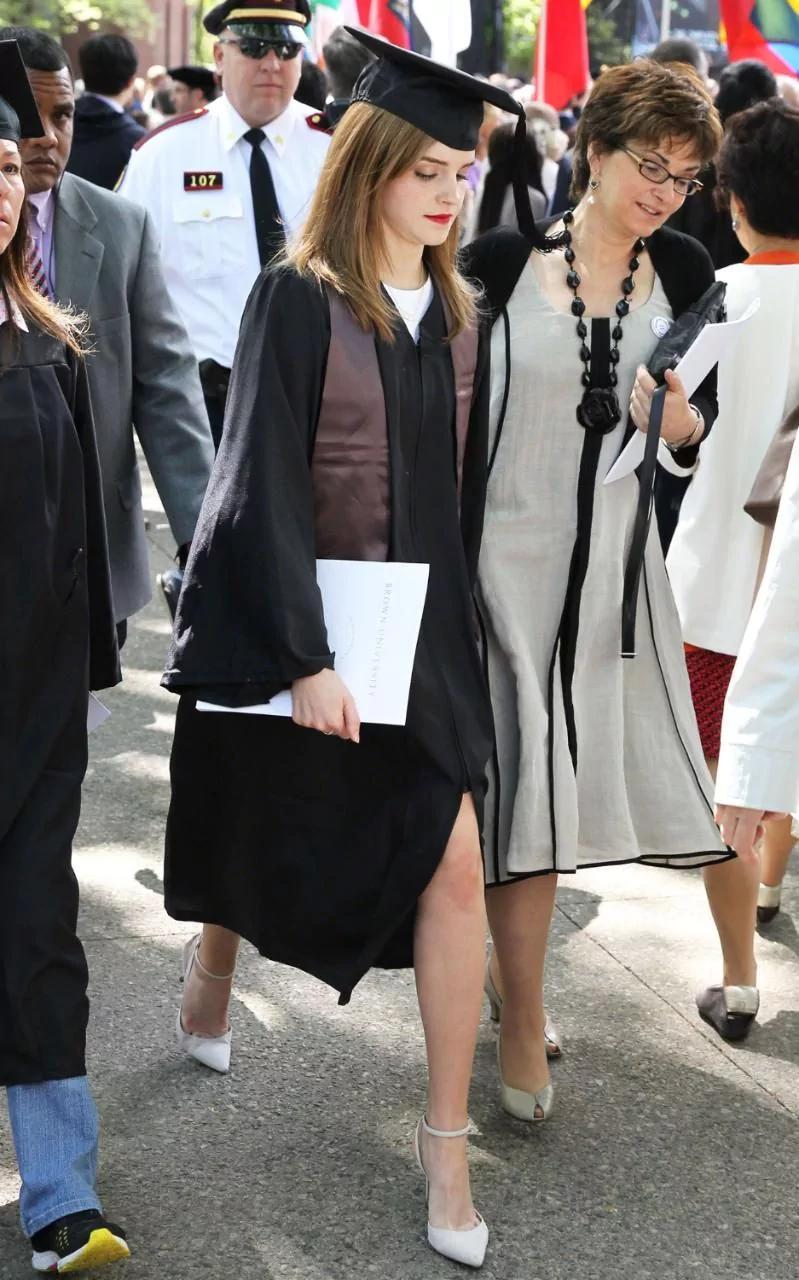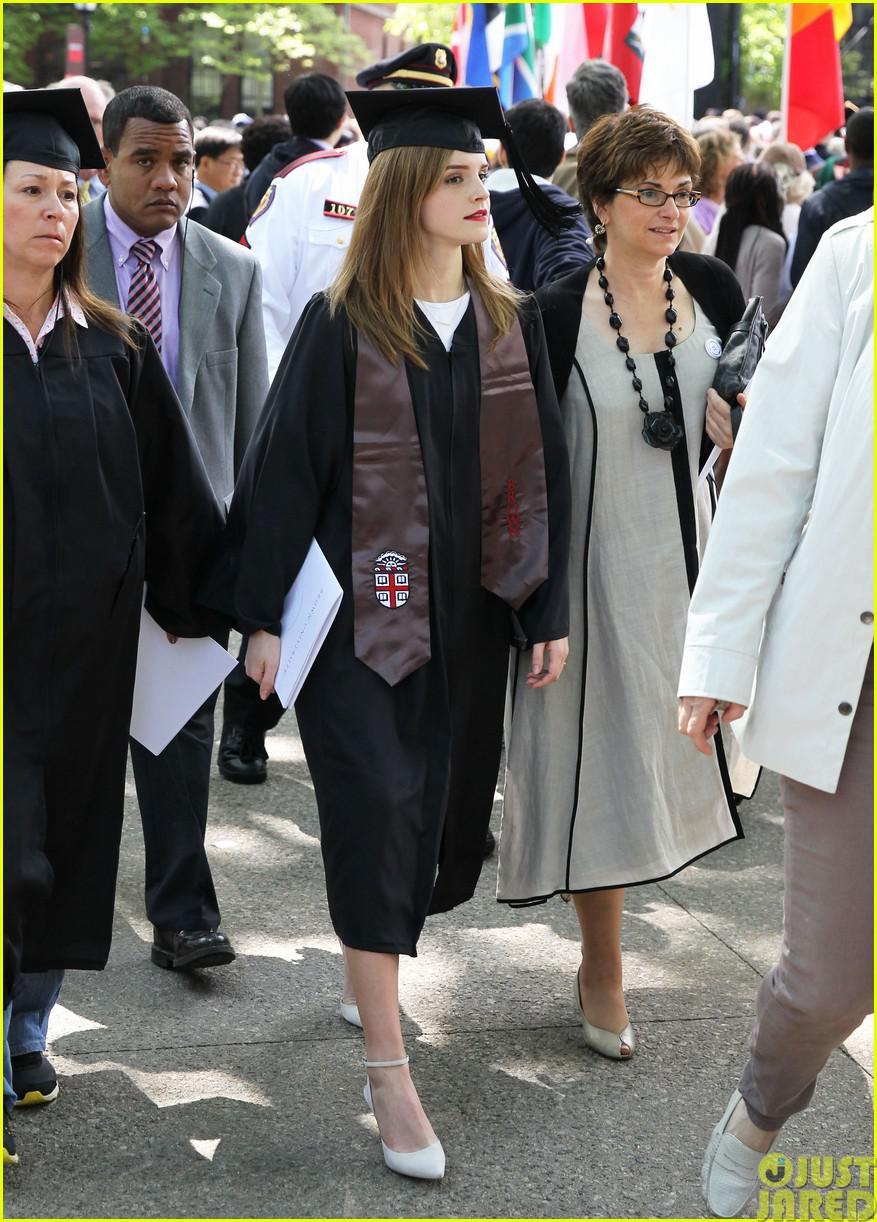The first image is the image on the left, the second image is the image on the right. Given the left and right images, does the statement "One image shows one male graduate posing with one female in the foreground." hold true? Answer yes or no. No. 